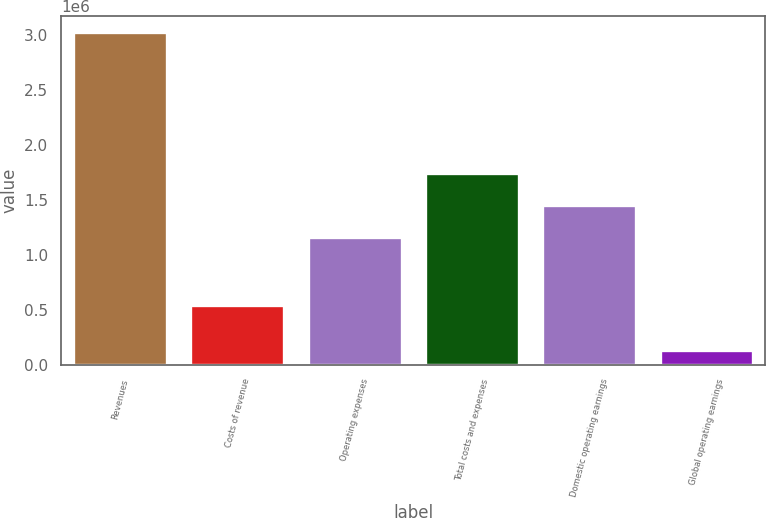<chart> <loc_0><loc_0><loc_500><loc_500><bar_chart><fcel>Revenues<fcel>Costs of revenue<fcel>Operating expenses<fcel>Total costs and expenses<fcel>Domestic operating earnings<fcel>Global operating earnings<nl><fcel>3.02179e+06<fcel>542210<fcel>1.16341e+06<fcel>1.74061e+06<fcel>1.45201e+06<fcel>135781<nl></chart> 